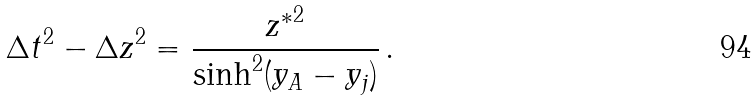Convert formula to latex. <formula><loc_0><loc_0><loc_500><loc_500>\Delta t ^ { 2 } - \Delta z ^ { 2 } = \frac { { z ^ { * } } ^ { 2 } } { \sinh ^ { 2 } ( y _ { A } - y _ { j } ) } \, .</formula> 